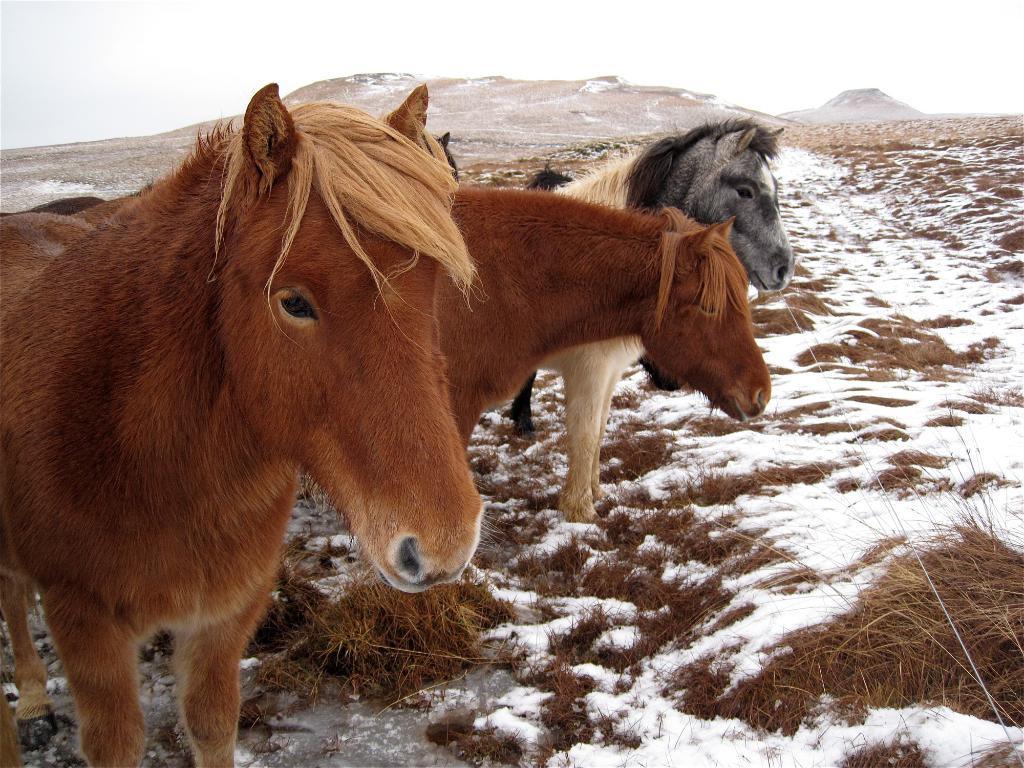Can you describe this image briefly? In this image there are three ponies standing on the floor. In the background there are hills. In front of them there is a snow and a dry grass on it. 